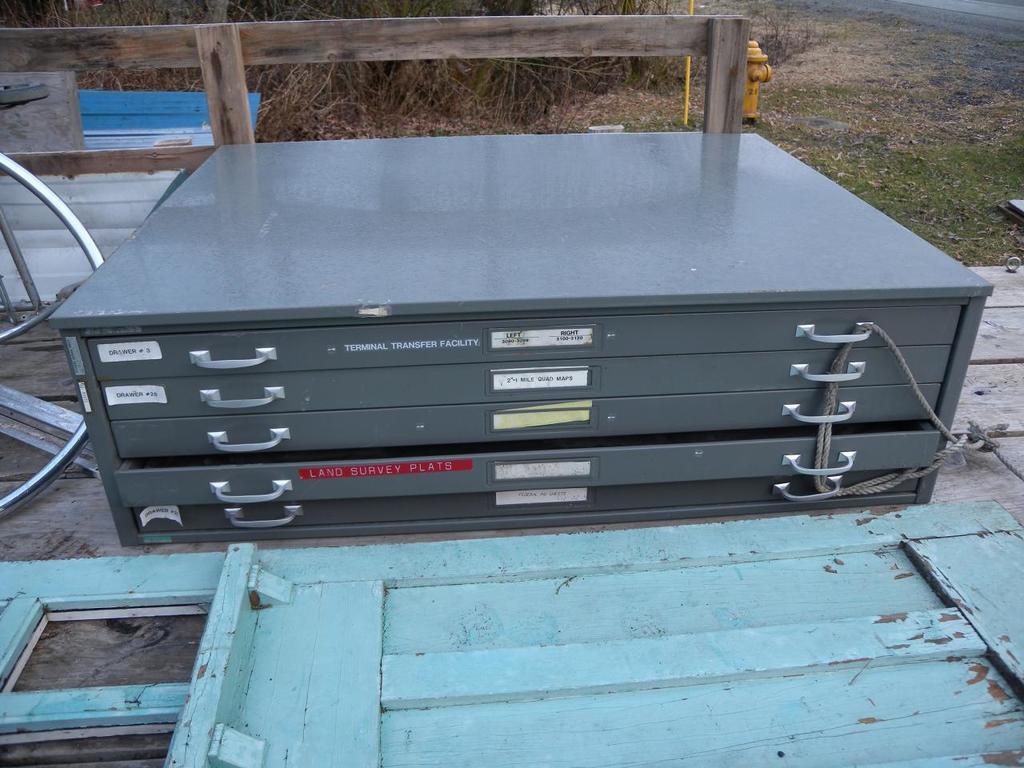What is in the second to the top drawer?
Ensure brevity in your answer.  Mile quad maps. 